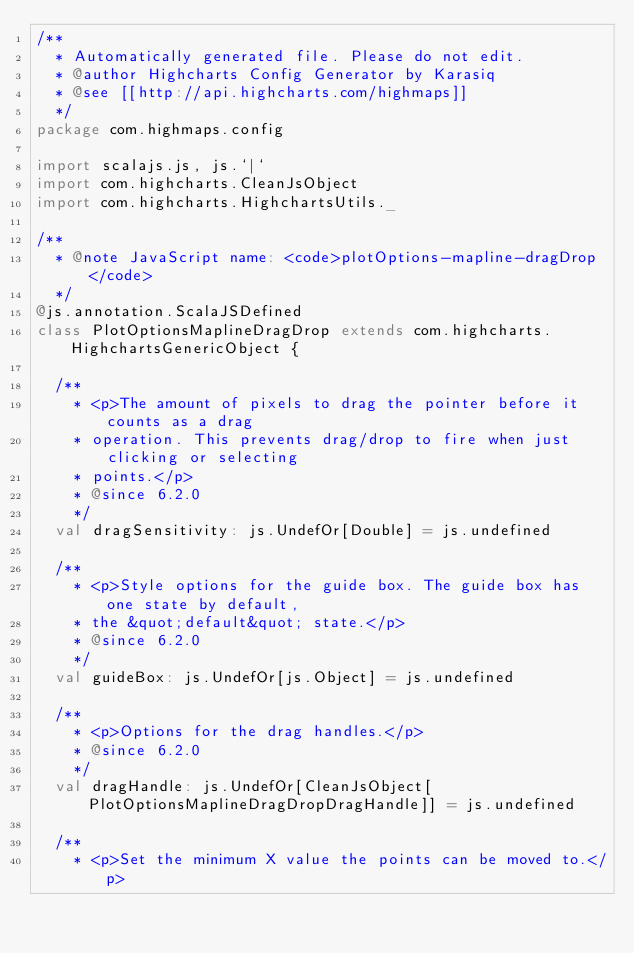<code> <loc_0><loc_0><loc_500><loc_500><_Scala_>/**
  * Automatically generated file. Please do not edit.
  * @author Highcharts Config Generator by Karasiq
  * @see [[http://api.highcharts.com/highmaps]]
  */
package com.highmaps.config

import scalajs.js, js.`|`
import com.highcharts.CleanJsObject
import com.highcharts.HighchartsUtils._

/**
  * @note JavaScript name: <code>plotOptions-mapline-dragDrop</code>
  */
@js.annotation.ScalaJSDefined
class PlotOptionsMaplineDragDrop extends com.highcharts.HighchartsGenericObject {

  /**
    * <p>The amount of pixels to drag the pointer before it counts as a drag
    * operation. This prevents drag/drop to fire when just clicking or selecting
    * points.</p>
    * @since 6.2.0
    */
  val dragSensitivity: js.UndefOr[Double] = js.undefined

  /**
    * <p>Style options for the guide box. The guide box has one state by default,
    * the &quot;default&quot; state.</p>
    * @since 6.2.0
    */
  val guideBox: js.UndefOr[js.Object] = js.undefined

  /**
    * <p>Options for the drag handles.</p>
    * @since 6.2.0
    */
  val dragHandle: js.UndefOr[CleanJsObject[PlotOptionsMaplineDragDropDragHandle]] = js.undefined

  /**
    * <p>Set the minimum X value the points can be moved to.</p></code> 